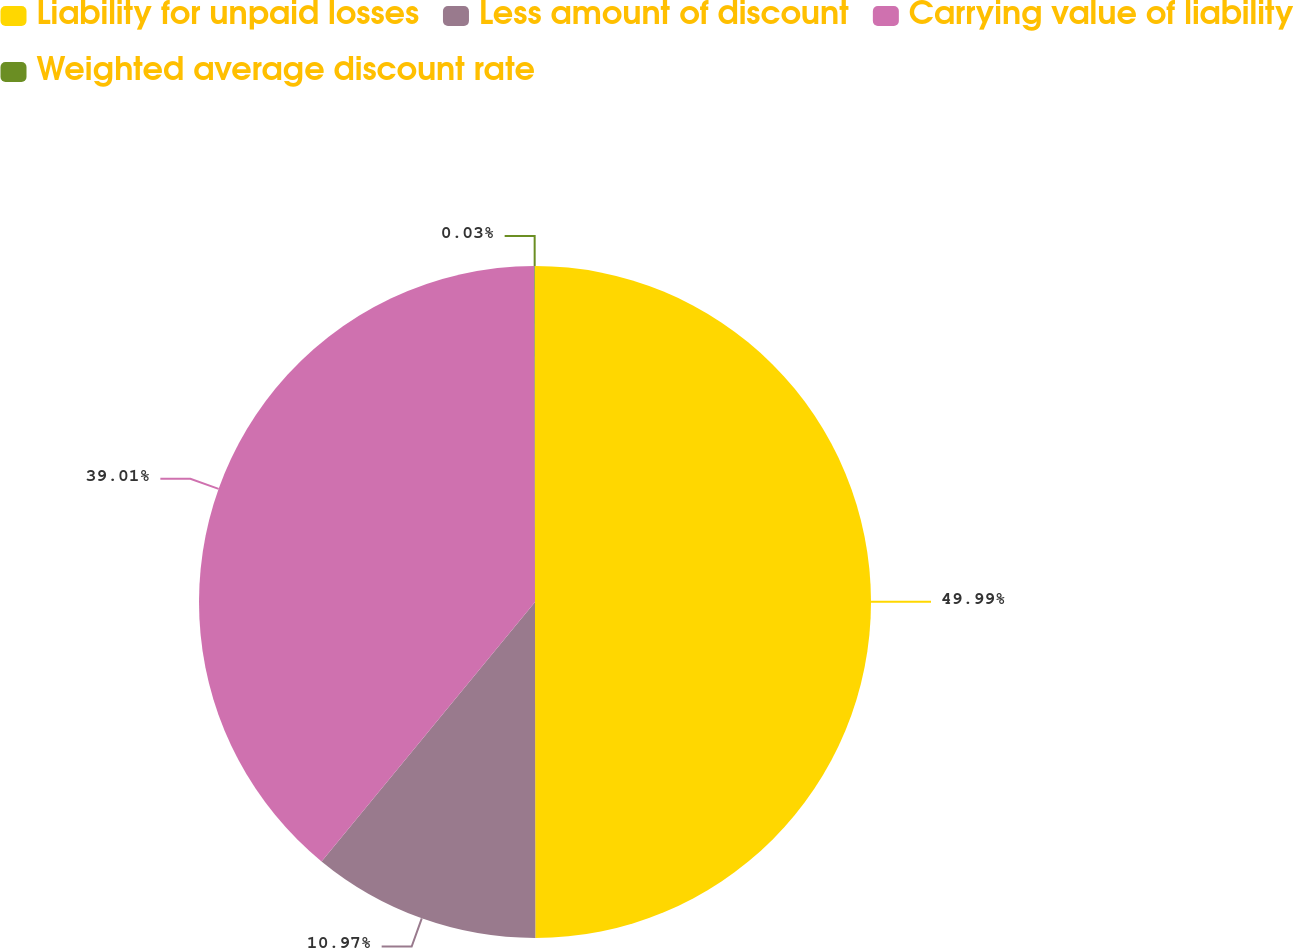<chart> <loc_0><loc_0><loc_500><loc_500><pie_chart><fcel>Liability for unpaid losses<fcel>Less amount of discount<fcel>Carrying value of liability<fcel>Weighted average discount rate<nl><fcel>49.98%<fcel>10.97%<fcel>39.01%<fcel>0.03%<nl></chart> 